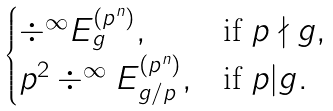Convert formula to latex. <formula><loc_0><loc_0><loc_500><loc_500>\begin{cases} \div ^ { \infty } E _ { g } ^ { ( p ^ { n } ) } , & \text {if } p \nmid g , \\ p ^ { 2 } \div ^ { \infty } E _ { g / p } ^ { ( p ^ { n } ) } , & \text {if } p | g . \end{cases}</formula> 